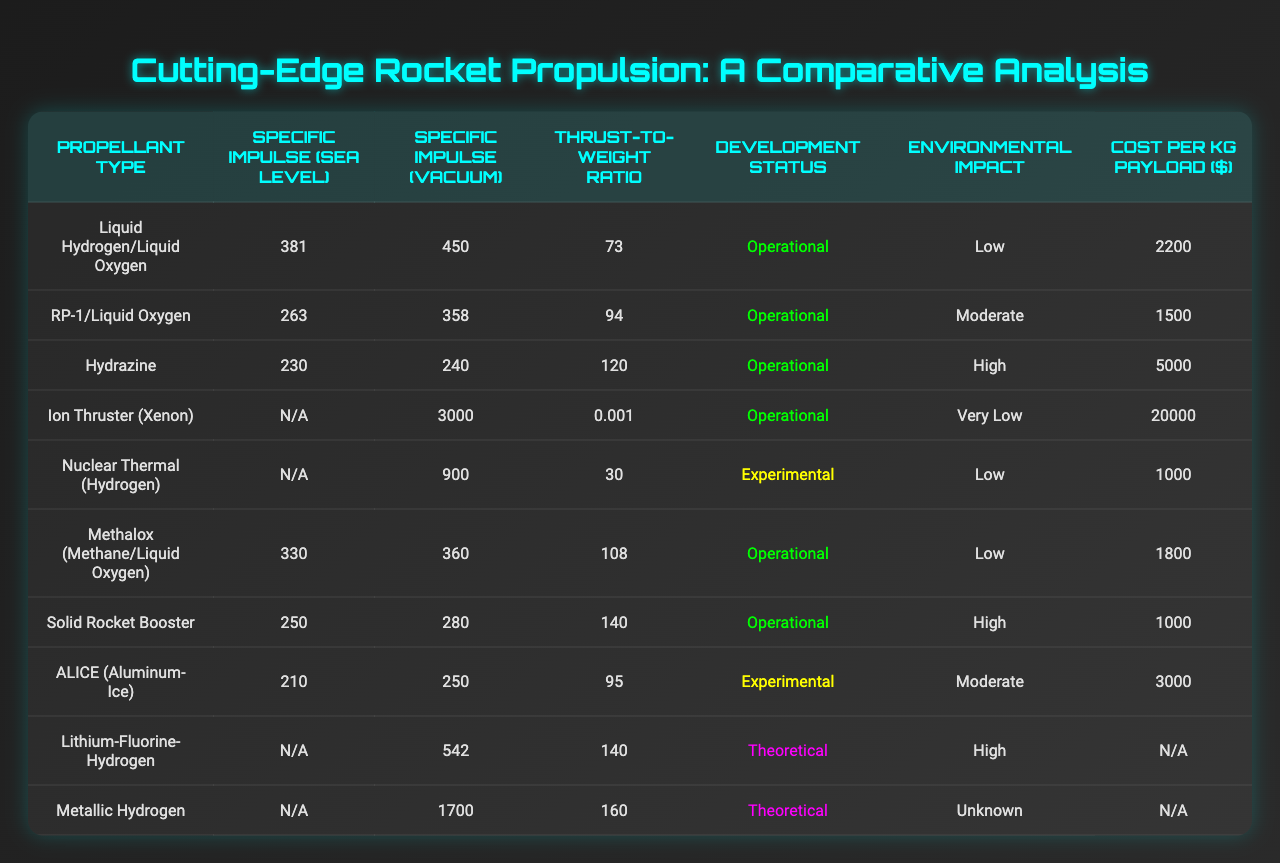What is the specific impulse (vacuum) of the Ion Thruster (Xenon)? The specific impulse (vacuum) of the Ion Thruster (Xenon) is listed directly in the table, which shows the value as 3000.
Answer: 3000 Which propellant has the highest cost per kg payload? By reviewing the cost per kg payload column, we see that the Ion Thruster (Xenon) has a cost of 20000, which is the highest value listed.
Answer: 20000 Is Metallic Hydrogen an operational propellant? The development status column for Metallic Hydrogen states "Theoretical", indicating that it is not operational.
Answer: No What is the average specific impulse (vacuum) of the operational propellants? The operational propellants are Liquid Hydrogen/Liquid Oxygen, RP-1/Liquid Oxygen, Hydrazine, Methalox (Methane/Liquid Oxygen), Solid Rocket Booster, and ALICE (Aluminum-Ice). Their specific impulses in vacuum are 450, 358, 240, 360, 280, and 250 respectively. The sum is 1938, and there are 6 operational types, so the average is 1938 / 6 = 323.
Answer: 323 What is the environmental impact of the propellant with the highest thrust-to-weight ratio? Checking the thrust-to-weight ratio, we find that Metallic Hydrogen has the highest value of 160. The environmental impact for Metallic Hydrogen is noted as "Unknown".
Answer: Unknown Which propellant has the lowest specific impulse (sea level)? Looking through the specific impulse (sea level) column, we see that Hydrazine has the lowest value, which is 230.
Answer: 230 Are all the experimental propellants also in the theoretical status? The experimental propellants are Nuclear Thermal (Hydrogen) and ALICE (Aluminum-Ice), which have development statuses of "Experimental" and "Theoretical" respectively, meaning they are not both in the same status.
Answer: No Calculate the difference in specific impulse (vacuum) between Liquid Hydrogen/Liquid Oxygen and Metallic Hydrogen. The specific impulse (vacuum) for Liquid Hydrogen/Liquid Oxygen is 450, and for Metallic Hydrogen, it is 1700. The difference is 1700 - 450 = 1250.
Answer: 1250 What percentage of the propellants listed have a low environmental impact? Among the 10 propellant types, those with low environmental impact are Liquid Hydrogen/Liquid Oxygen, Nuclear Thermal (Hydrogen), Methalox (Methane/Liquid Oxygen), Solid Rocket Booster, and ALICE (Aluminum-Ice) making a total of 5. The percentage is (5 / 10) * 100 = 50%.
Answer: 50% Which propellant has a specific impulse (sea level) value of N/A? The propellant types with an N/A value for specific impulse (sea level) are Ion Thruster (Xenon), Nuclear Thermal (Hydrogen), Metallic Hydrogen, and Lithium-Fluorine-Hydrogen.
Answer: Ion Thruster (Xenon), Nuclear Thermal (Hydrogen), Metallic Hydrogen, Lithium-Fluorine-Hydrogen 